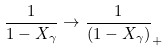<formula> <loc_0><loc_0><loc_500><loc_500>\frac { 1 } { 1 - X _ { \gamma } } \rightarrow \frac { 1 } { ( 1 - X _ { \gamma } ) } _ { + }</formula> 